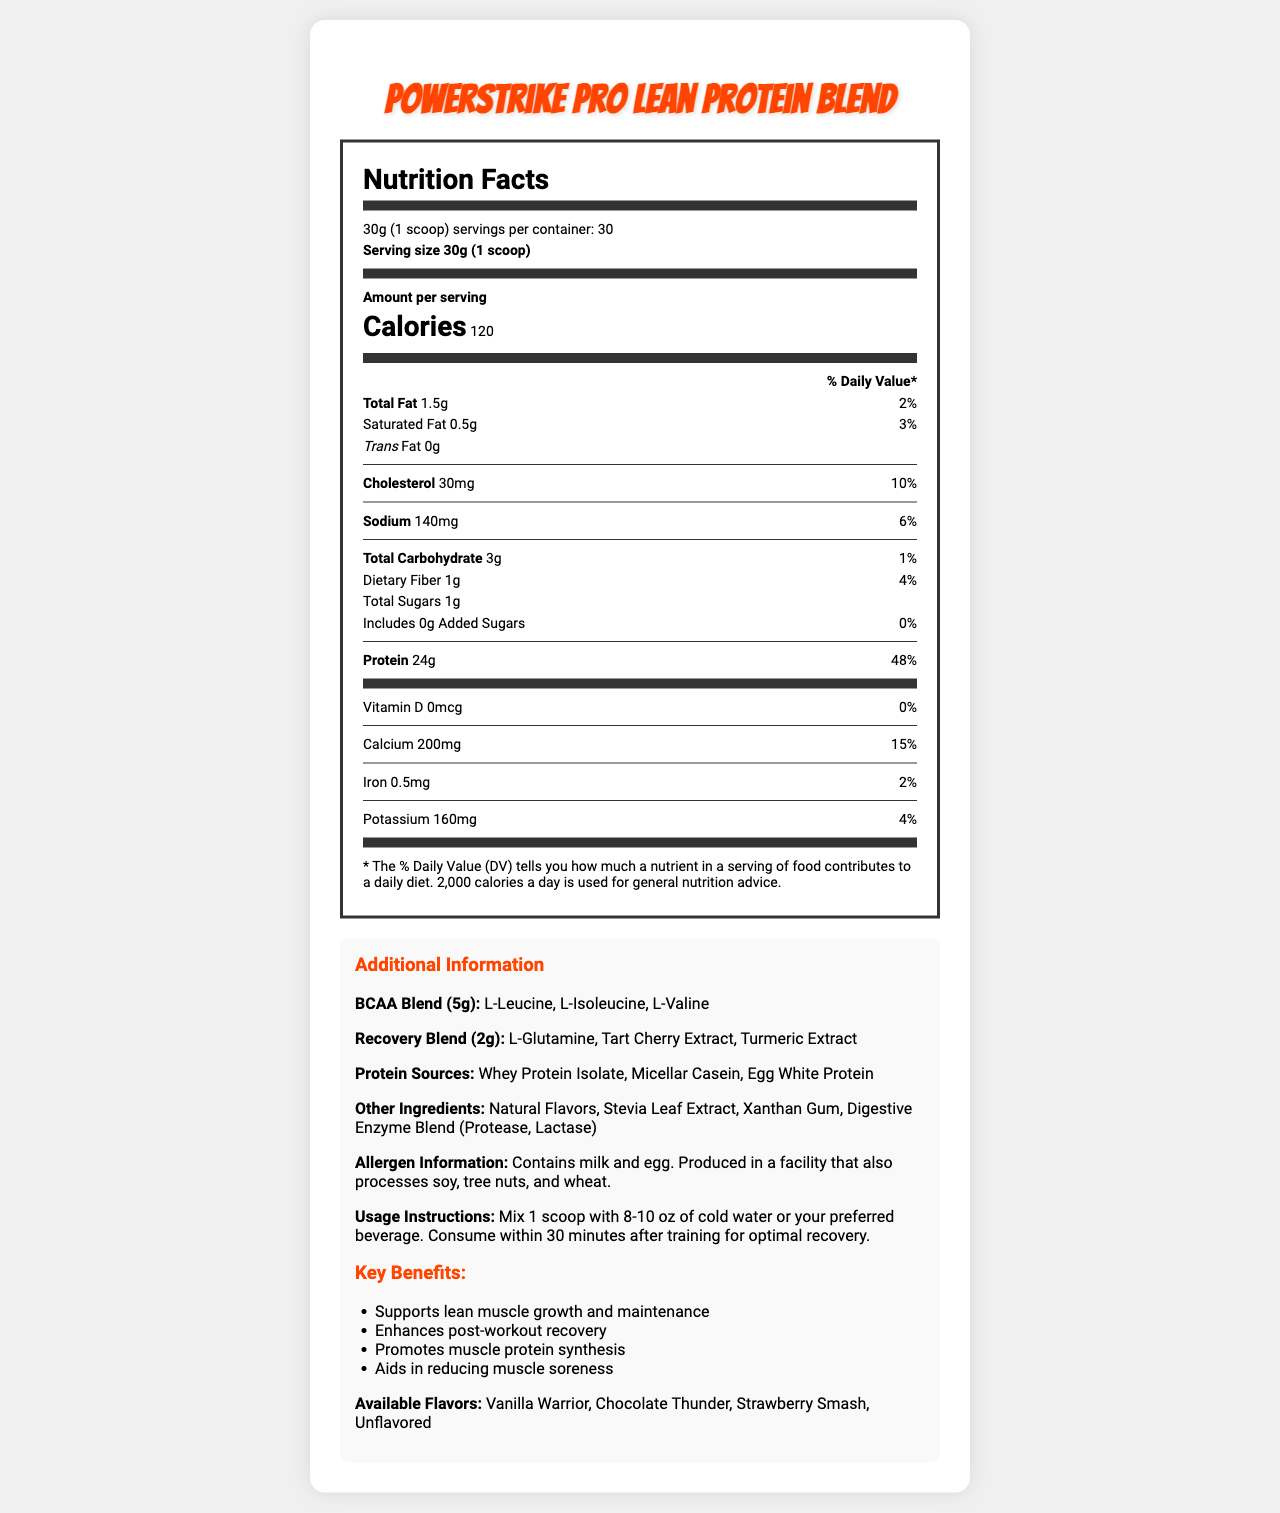what is the serving size of PowerStrike Pro Lean Protein Blend? The serving size is explicitly mentioned as 30g (1 scoop) in the document.
Answer: 30g (1 scoop) how many calories are in a single serving? The document specifies that each serving contains 120 calories.
Answer: 120 what is the total fat content per serving? The total fat content per serving is listed as 1.5g.
Answer: 1.5g how much protein is in each serving? The amount of protein per serving is 24g as noted in the document.
Answer: 24g what flavors are available for this protein supplement? The available flavors are listed in the "Additional Information" section.
Answer: Vanilla Warrior, Chocolate Thunder, Strawberry Smash, Unflavored Which of the following is used in the BCAA Blend? A. L-Lysine B. L-Leucine C. L-Tyrosine The BCAA Blend components listed are L-Leucine, L-Isoleucine, and L-Valine.
Answer: B. L-Leucine What is the daily value percentage of calcium per serving? The daily value of calcium per serving is indicated as 15%.
Answer: 15% Does the product contain added sugars? The document specifies that there are 0g of added sugars.
Answer: No What is the amount of dietary fiber per serving? The dietary fiber per serving is specifically noted as 1g.
Answer: 1g What are the benefits of using this protein supplement? The key benefits are clearly listed under the "Key Benefits" section.
Answer: Supports lean muscle growth and maintenance, Enhances post-workout recovery, Promotes muscle protein synthesis, Aids in reducing muscle soreness does the protein blend contain soy? The allergen information states it contains milk and egg but does not mention soy. However, it is produced in a facility that processes soy.
Answer: No What other ingredients are included in the protein blend? A. Natural Flavors, Stevia Leaf Extract, Xanthan Gum B. Cocoa Powder, Sucralose, Micellar Casein C. L-Leucine, L-Glutamine, Whey Protein Isolate The "Other Ingredients" section lists Natural Flavors, Stevia Leaf Extract, Xanthan Gum as part of the blend.
Answer: A. Natural Flavors, Stevia Leaf Extract, Xanthan Gum Summarize the main idea of the document. The document is comprehensive, containing information on nutrient content, ingredients, and additional usage instructions, giving a complete profile of the PowerStrike Pro Lean Protein Blend.
Answer: The document provides detailed nutrition facts and additional information for the PowerStrike Pro Lean Protein Blend, a protein supplement powder. It highlights serving size, calorie content, various nutrient amounts, and also contains information on BCAA and recovery blends, allergen information, usage instructions, key benefits, and available flavors. What is the macronutrient with the highest amount per serving? Protein has the highest amount per serving at 24g compared to other macronutrients listed.
Answer: Protein How many grams of total carbohydrates are there per serving? The total carbohydrate content per serving is explicitly listed as 3g.
Answer: 3g what is the brand of digestive enzyme included in the product? The document mentions a "Digestive Enzyme Blend" but does not specify a brand name.
Answer: Not enough information 